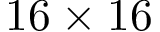Convert formula to latex. <formula><loc_0><loc_0><loc_500><loc_500>1 6 \times 1 6</formula> 